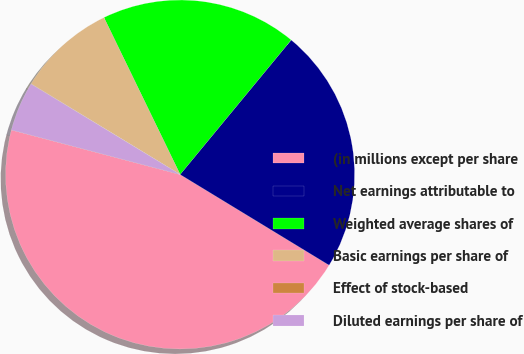<chart> <loc_0><loc_0><loc_500><loc_500><pie_chart><fcel>(in millions except per share<fcel>Net earnings attributable to<fcel>Weighted average shares of<fcel>Basic earnings per share of<fcel>Effect of stock-based<fcel>Diluted earnings per share of<nl><fcel>45.41%<fcel>22.72%<fcel>18.18%<fcel>9.1%<fcel>0.03%<fcel>4.57%<nl></chart> 